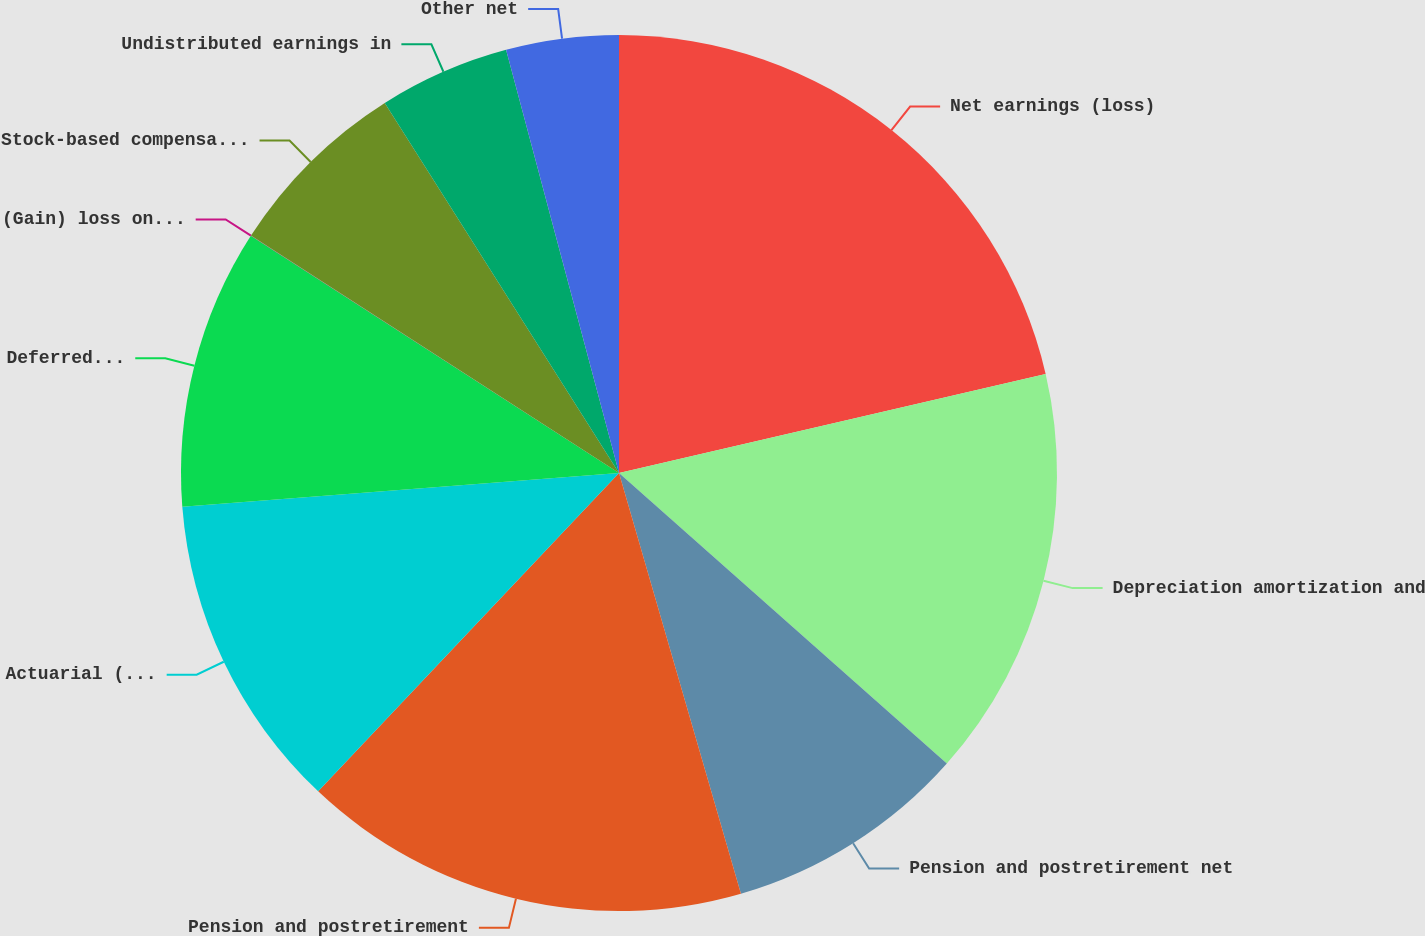Convert chart. <chart><loc_0><loc_0><loc_500><loc_500><pie_chart><fcel>Net earnings (loss)<fcel>Depreciation amortization and<fcel>Pension and postretirement net<fcel>Pension and postretirement<fcel>Actuarial (gain) loss on<fcel>Deferred income taxes net<fcel>(Gain) loss on disposition of<fcel>Stock-based compensation<fcel>Undistributed earnings in<fcel>Other net<nl><fcel>21.37%<fcel>15.17%<fcel>8.97%<fcel>16.54%<fcel>11.72%<fcel>10.34%<fcel>0.01%<fcel>6.9%<fcel>4.83%<fcel>4.15%<nl></chart> 